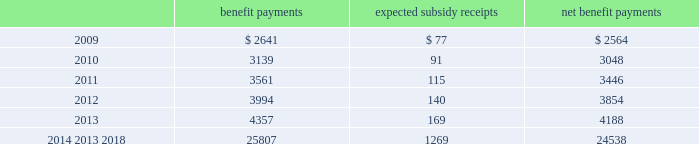Mastercard incorporated notes to consolidated financial statements 2014 ( continued ) ( in thousands , except percent and per share data ) the company does not make any contributions to its postretirement plan other than funding benefits payments .
The table summarizes expected net benefit payments from the company 2019s general assets through 2018 : benefit payments expected subsidy receipts benefit payments .
The company provides limited postemployment benefits to eligible former u.s .
Employees , primarily severance under a formal severance plan ( the 201cseverance plan 201d ) .
The company accounts for severance expense in accordance with sfas no .
112 , 201cemployers 2019 accounting for postemployment benefits 201d by accruing the expected cost of the severance benefits expected to be provided to former employees after employment over their relevant service periods .
The company updates the assumptions in determining the severance accrual by evaluating the actual severance activity and long-term trends underlying the assumptions .
As a result of updating the assumptions , the company recorded severance expense ( benefit ) related to the severance plan of $ 2643 , $ ( 3418 ) and $ 8400 , respectively , during the years 2008 , 2007 and 2006 .
The company has an accrued liability related to the severance plan and other severance obligations in the amount of $ 63863 and $ 56172 at december 31 , 2008 and 2007 , respectively .
Note 13 .
Debt on april 28 , 2008 , the company extended its committed unsecured revolving credit facility , dated as of april 28 , 2006 ( the 201ccredit facility 201d ) , for an additional year .
The new expiration date of the credit facility is april 26 , 2011 .
The available funding under the credit facility will remain at $ 2500000 through april 27 , 2010 and then decrease to $ 2000000 during the final year of the credit facility agreement .
Other terms and conditions in the credit facility remain unchanged .
The company 2019s option to request that each lender under the credit facility extend its commitment was provided pursuant to the original terms of the credit facility agreement .
Borrowings under the facility are available to provide liquidity in the event of one or more settlement failures by mastercard international customers and , subject to a limit of $ 500000 , for general corporate purposes .
A facility fee of 8 basis points on the total commitment , or approximately $ 2030 , is paid annually .
Interest on borrowings under the credit facility would be charged at the london interbank offered rate ( libor ) plus an applicable margin of 37 basis points or an alternative base rate , and a utilization fee of 10 basis points would be charged if outstanding borrowings under the facility exceed 50% ( 50 % ) of commitments .
The facility fee and borrowing cost are contingent upon the company 2019s credit rating .
The company also agreed to pay upfront fees of $ 1250 and administrative fees of $ 325 for the credit facility which are being amortized straight- line over three years .
Facility and other fees associated with the credit facility or prior facilities totaled $ 2353 , $ 2477 and $ 2717 for each of the years ended december 31 , 2008 , 2007 and 2006 , respectively .
Mastercard was in compliance with the covenants of the credit facility and had no borrowings under the credit facility at december 31 , 2008 or december 31 , 2007 .
The majority of credit facility lenders are customers or affiliates of customers of mastercard international .
In june 1998 , mastercard international issued ten-year unsecured , subordinated notes ( the 201cnotes 201d ) paying a fixed interest rate of 6.67% ( 6.67 % ) per annum .
Mastercard repaid the entire principal amount of $ 80000 on june 30 .
What was the percent of the expected subsidy receipts to the expected benefit payments? 
Computations: (77 / 2641)
Answer: 0.02916. 